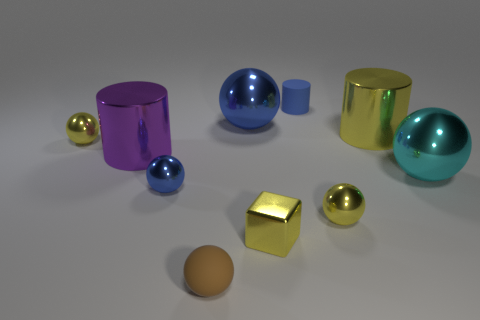Subtract all blue balls. How many balls are left? 4 Subtract all green cubes. How many yellow spheres are left? 2 Subtract 2 balls. How many balls are left? 4 Subtract all yellow spheres. How many spheres are left? 4 Subtract all cyan cylinders. Subtract all red balls. How many cylinders are left? 3 Subtract all blocks. How many objects are left? 9 Subtract all tiny brown matte spheres. Subtract all large yellow metal things. How many objects are left? 8 Add 5 small metallic spheres. How many small metallic spheres are left? 8 Add 5 large rubber balls. How many large rubber balls exist? 5 Subtract 0 red balls. How many objects are left? 10 